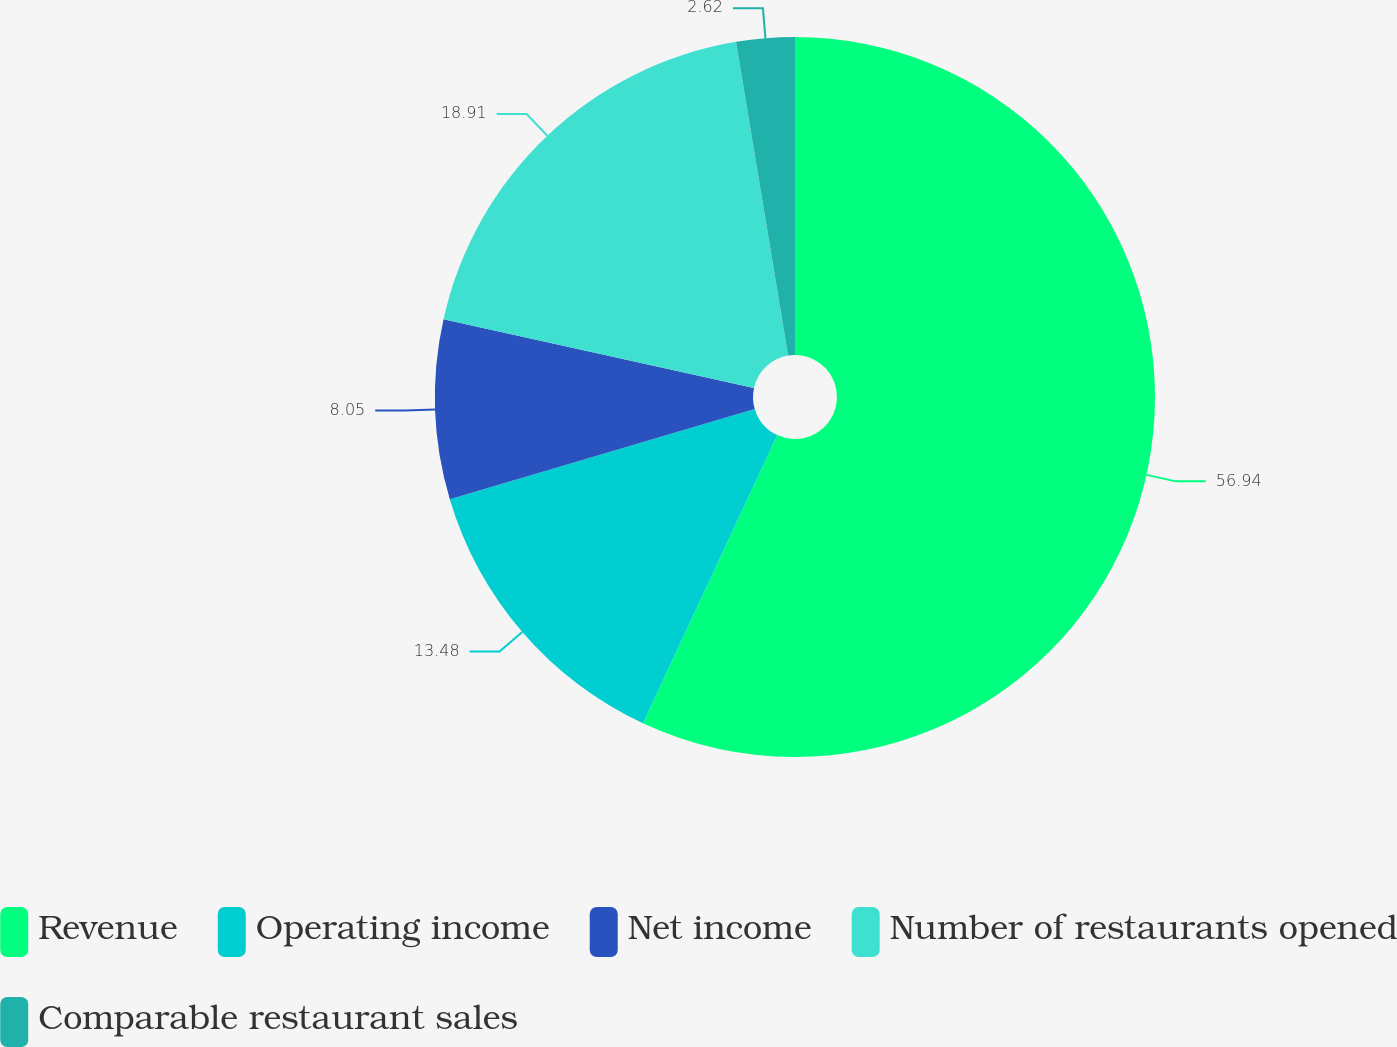Convert chart to OTSL. <chart><loc_0><loc_0><loc_500><loc_500><pie_chart><fcel>Revenue<fcel>Operating income<fcel>Net income<fcel>Number of restaurants opened<fcel>Comparable restaurant sales<nl><fcel>56.94%<fcel>13.48%<fcel>8.05%<fcel>18.91%<fcel>2.62%<nl></chart> 